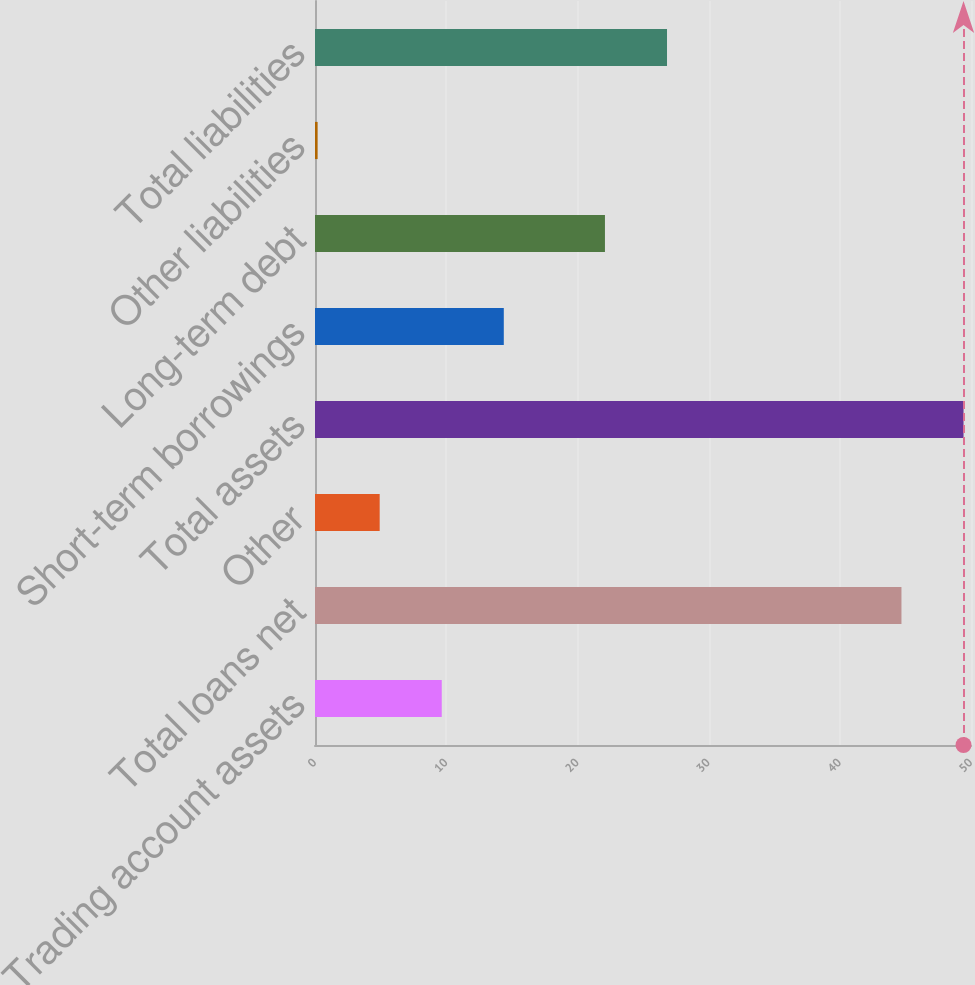<chart> <loc_0><loc_0><loc_500><loc_500><bar_chart><fcel>Trading account assets<fcel>Total loans net<fcel>Other<fcel>Total assets<fcel>Short-term borrowings<fcel>Long-term debt<fcel>Other liabilities<fcel>Total liabilities<nl><fcel>9.66<fcel>44.7<fcel>4.93<fcel>49.43<fcel>14.39<fcel>22.1<fcel>0.2<fcel>26.83<nl></chart> 